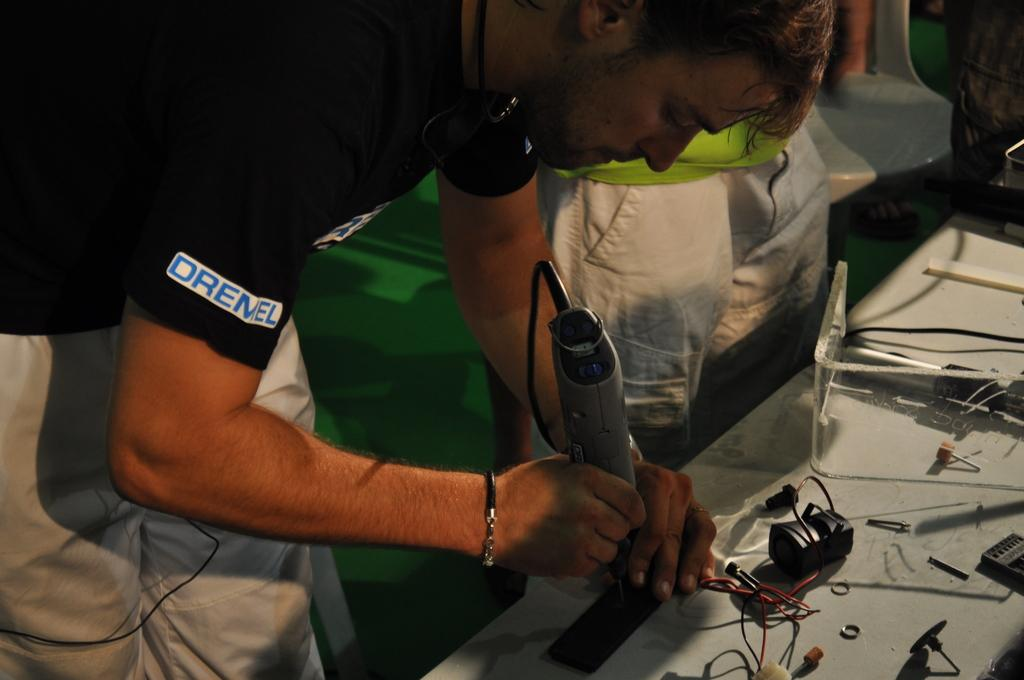<image>
Relay a brief, clear account of the picture shown. A man is using a hand tool while wearing a shirt that says Oremel on it. 